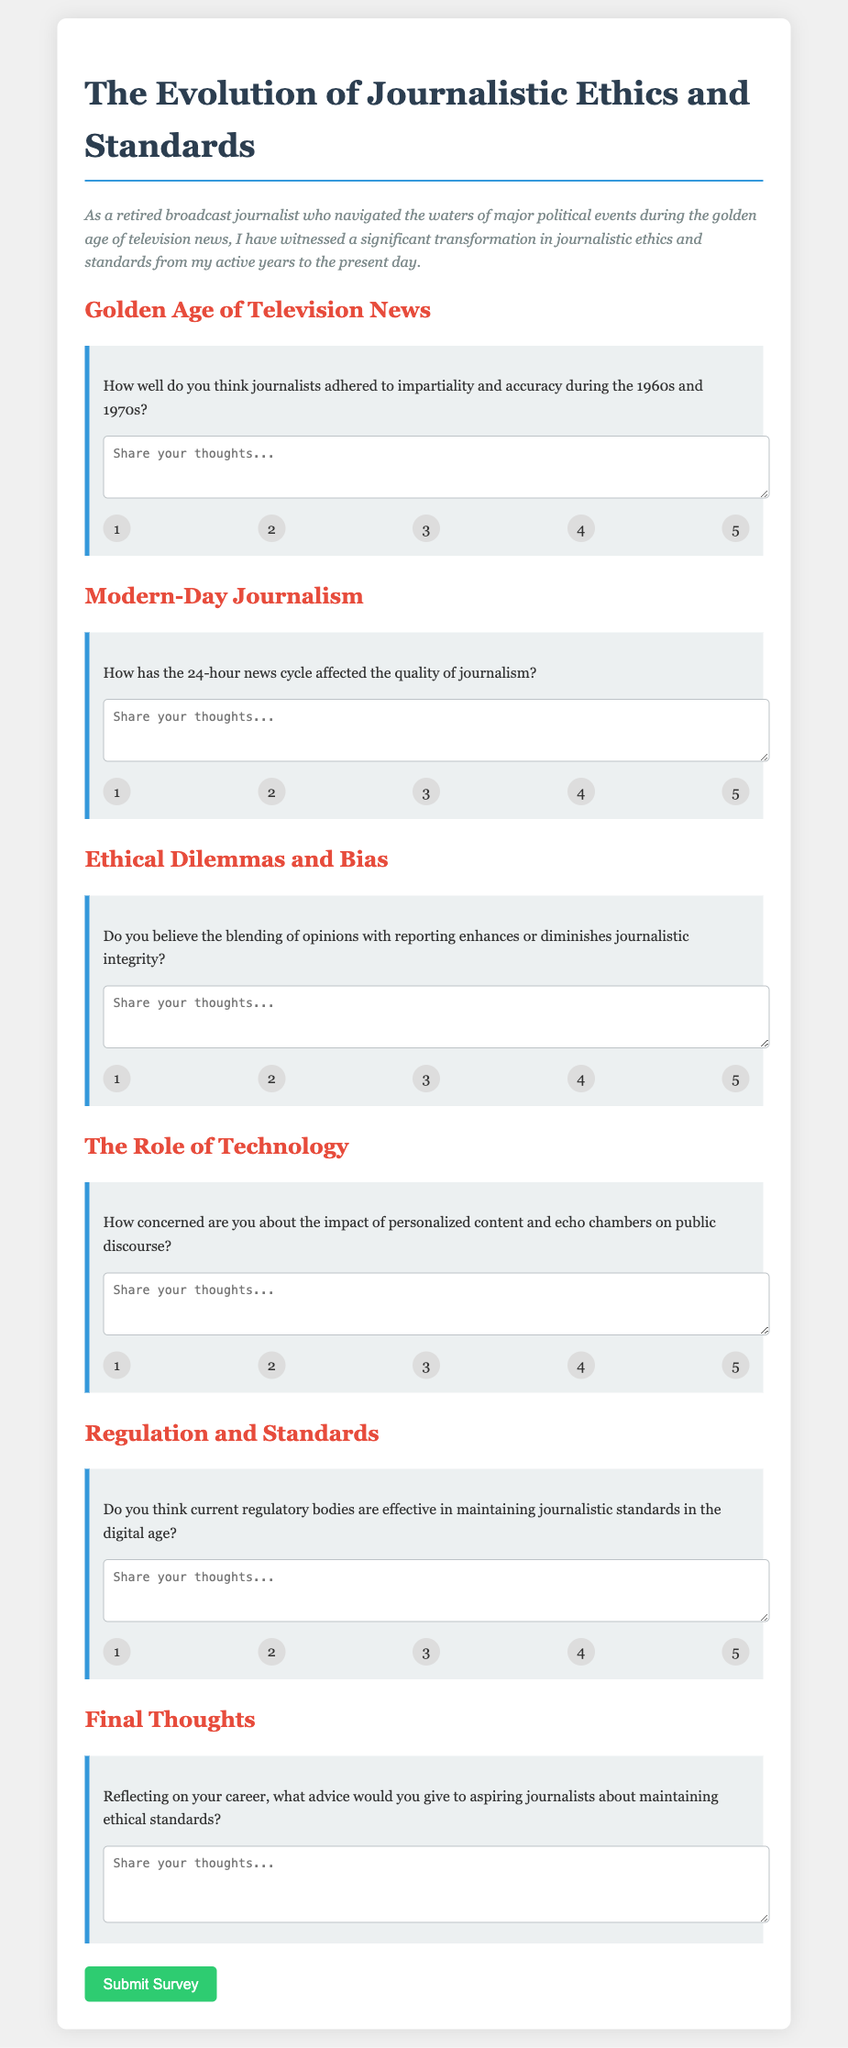How many sections are in the survey form? The document has multiple distinct sections based on different themes related to journalism. The sections are specifically labeled in the form.
Answer: 5 What is the title of the survey? The title of the survey reflects its focus on journalistic ethics and standards, indicating the overarching theme of the document.
Answer: The Evolution of Journalistic Ethics and Standards In which decades did the respondent evaluate journalistic adherence to impartiality and accuracy? The document specifies that the evaluation of journalistic practices is set in the context of specific decades, indicating the time frame of interest.
Answer: 1960s and 1970s What question is asked concerning modern-day journalism? The document includes specific queries aimed at understanding contemporary issues in journalism, showcasing the focus of inquiry.
Answer: How has the 24-hour news cycle affected the quality of journalism? What is the rating scale used in the survey? The survey utilizes a rating system for responses, indicating the mechanism through which participants can express their views quantitatively.
Answer: 1 to 5 What is the focus of the last section of the survey? The last section of the survey encourages reflection on career experiences and advice for future journalists, indicating its conclusive purpose.
Answer: Final Thoughts Do participants provide their answers in a paragraph format or a structured format? The design of the survey specifies how participants are expected to record their thoughts, differentiating between response styles.
Answer: Structured format (textarea) 